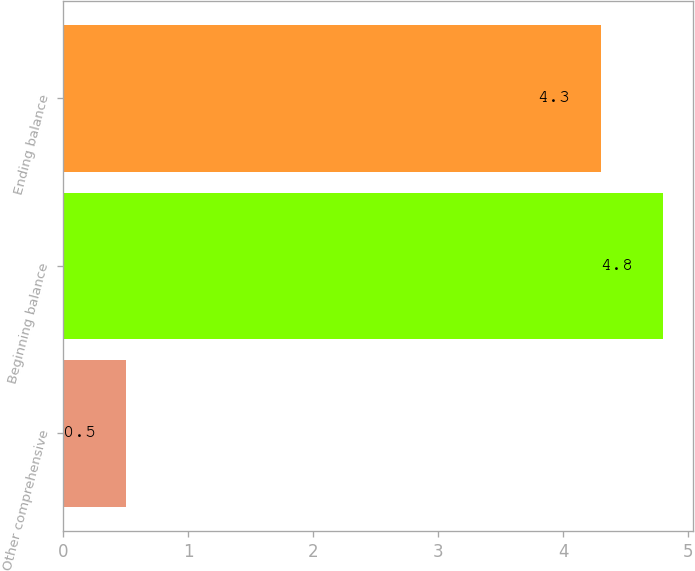Convert chart. <chart><loc_0><loc_0><loc_500><loc_500><bar_chart><fcel>Other comprehensive<fcel>Beginning balance<fcel>Ending balance<nl><fcel>0.5<fcel>4.8<fcel>4.3<nl></chart> 